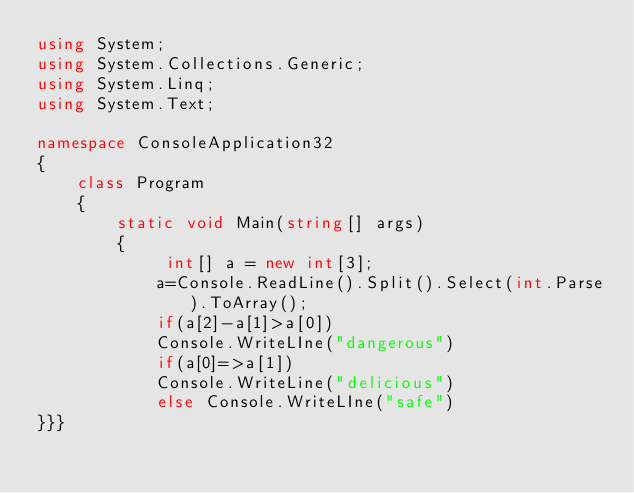<code> <loc_0><loc_0><loc_500><loc_500><_C#_>using System;
using System.Collections.Generic;
using System.Linq;
using System.Text;
 
namespace ConsoleApplication32
{
    class Program
    {
        static void Main(string[] args)
        {
             int[] a = new int[3];
            a=Console.ReadLine().Split().Select(int.Parse).ToArray();
            if(a[2]-a[1]>a[0])
            Console.WriteLIne("dangerous")
            if(a[0]=>a[1])
            Console.WriteLine("delicious")
            else Console.WriteLIne("safe")
}}}

</code> 